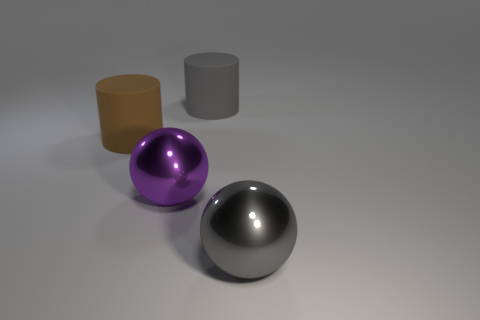How many objects are either large purple shiny things on the right side of the large brown matte cylinder or big blue matte things?
Give a very brief answer. 1. Does the brown object have the same size as the metallic sphere that is on the left side of the big gray rubber cylinder?
Ensure brevity in your answer.  Yes. What number of small objects are gray shiny cylinders or gray shiny objects?
Provide a succinct answer. 0. The large brown thing is what shape?
Ensure brevity in your answer.  Cylinder. Are there any other large cylinders made of the same material as the big gray cylinder?
Make the answer very short. Yes. Are there more brown objects than rubber cylinders?
Your response must be concise. No. Does the large brown cylinder have the same material as the large gray cylinder?
Your response must be concise. Yes. What number of shiny objects are big cylinders or cyan spheres?
Offer a very short reply. 0. What is the color of the other metallic thing that is the same size as the purple metallic object?
Your response must be concise. Gray. What number of other metallic objects are the same shape as the purple metallic thing?
Your response must be concise. 1. 